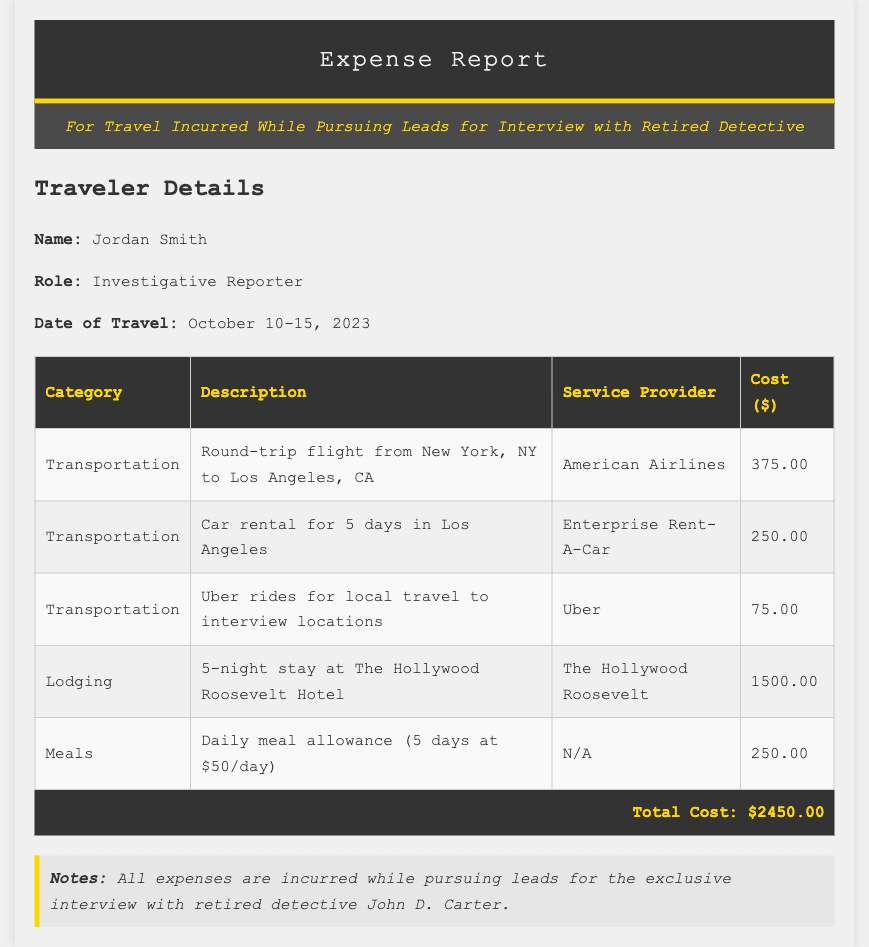what is the name of the traveler? The traveler's name is stated at the beginning of the document.
Answer: Jordan Smith what is the role of the traveler? The traveler's role is mentioned right after their name.
Answer: Investigative Reporter what are the travel dates? The travel dates can be found in the traveler details section of the document.
Answer: October 10-15, 2023 how much was spent on lodging? The lodging cost is listed in the expense table under the lodging category.
Answer: 1500.00 what is the total cost of the expenses? The total cost is summed up at the bottom of the expenses table.
Answer: 2450.00 how much did the round-trip flight cost? The cost for the round-trip flight can be found in the transportation section of the table.
Answer: 375.00 who was the service provider for the car rental? The service provider for the car rental is provided in the expense details.
Answer: Enterprise Rent-A-Car what was the daily meal allowance? The daily meal allowance is detailed in the meals section of the expense table.
Answer: 50/day what is the purpose of the travel? The purpose is noted in the header of the expense report.
Answer: Pursuing leads for interview with retired detective John D. Carter 